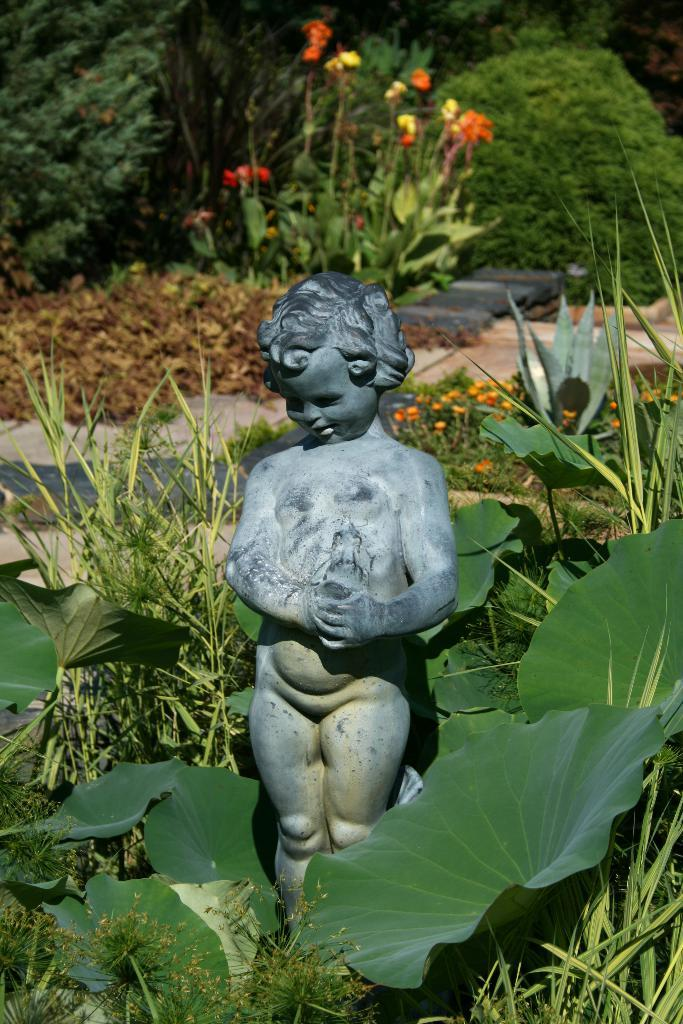What is the main subject of focus of the image? There is a statue in the image. What is located around the statue? The statue is surrounded by plants. What can be seen in the background of the image? There are trees visible in the background of the image. How many yaks are participating in the feast depicted in the image? There are no yaks or feast present in the image; it features a statue surrounded by plants with trees in the background. 